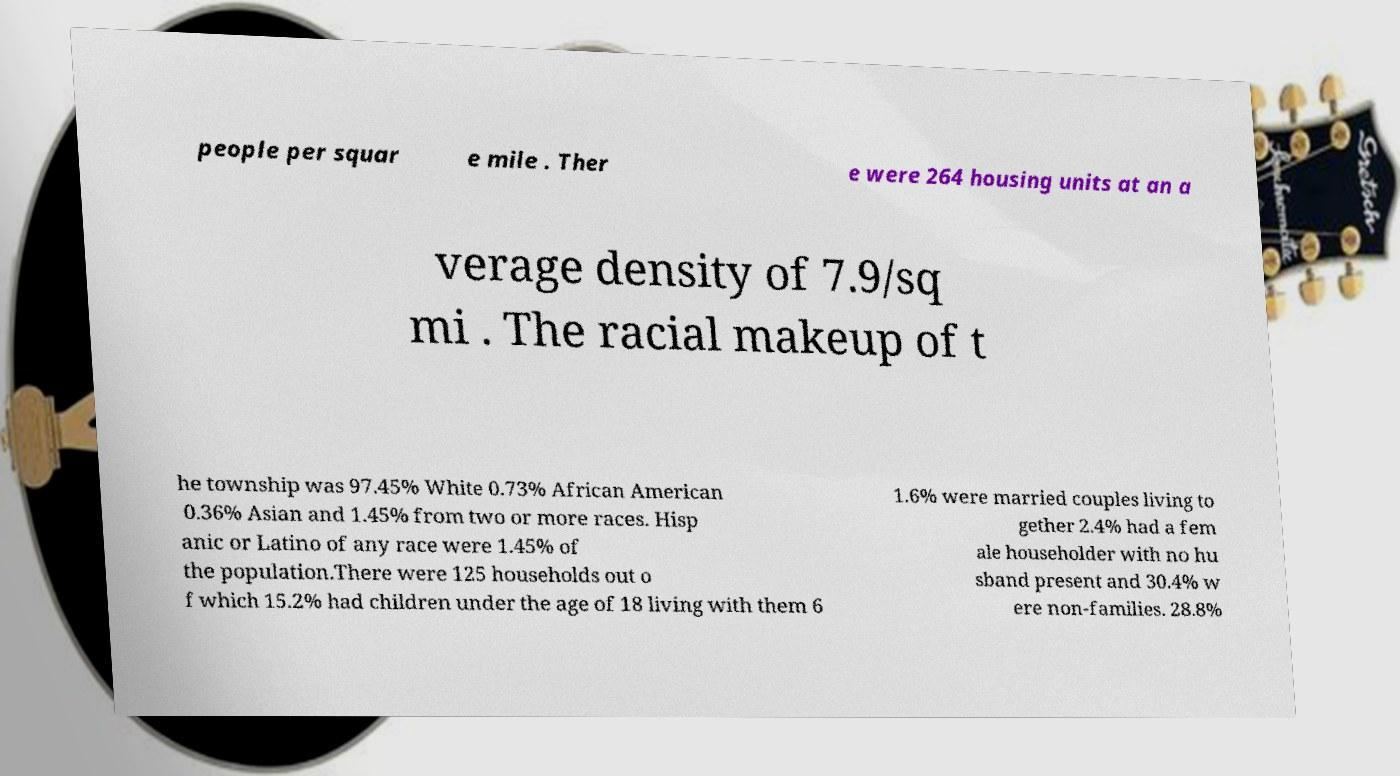Can you read and provide the text displayed in the image?This photo seems to have some interesting text. Can you extract and type it out for me? people per squar e mile . Ther e were 264 housing units at an a verage density of 7.9/sq mi . The racial makeup of t he township was 97.45% White 0.73% African American 0.36% Asian and 1.45% from two or more races. Hisp anic or Latino of any race were 1.45% of the population.There were 125 households out o f which 15.2% had children under the age of 18 living with them 6 1.6% were married couples living to gether 2.4% had a fem ale householder with no hu sband present and 30.4% w ere non-families. 28.8% 